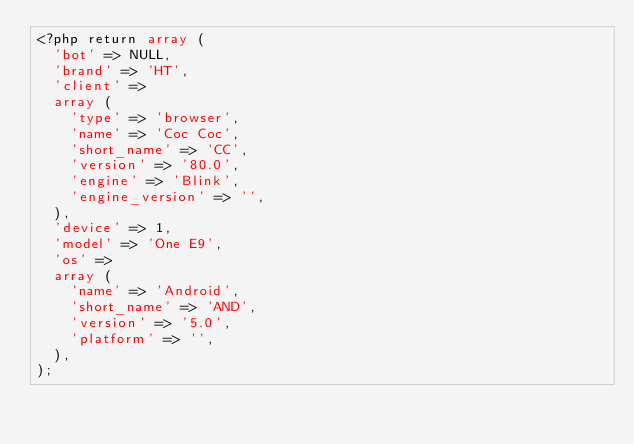<code> <loc_0><loc_0><loc_500><loc_500><_PHP_><?php return array (
  'bot' => NULL,
  'brand' => 'HT',
  'client' => 
  array (
    'type' => 'browser',
    'name' => 'Coc Coc',
    'short_name' => 'CC',
    'version' => '80.0',
    'engine' => 'Blink',
    'engine_version' => '',
  ),
  'device' => 1,
  'model' => 'One E9',
  'os' => 
  array (
    'name' => 'Android',
    'short_name' => 'AND',
    'version' => '5.0',
    'platform' => '',
  ),
);</code> 